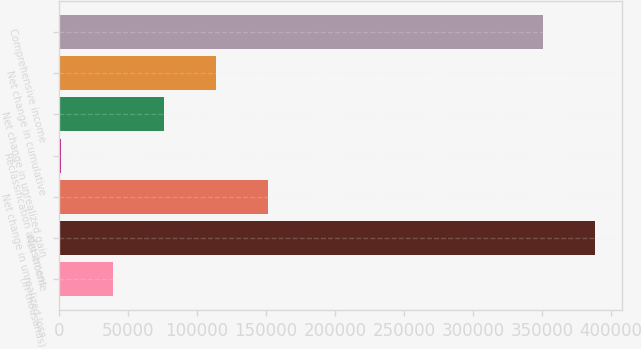Convert chart. <chart><loc_0><loc_0><loc_500><loc_500><bar_chart><fcel>(In thousands)<fcel>Net income<fcel>Net change in unrealized loss<fcel>Reclassification adjustment<fcel>Net change in unrealized gain<fcel>Net change in cumulative<fcel>Comprehensive income<nl><fcel>39022<fcel>388380<fcel>151228<fcel>1620<fcel>76424<fcel>113826<fcel>350978<nl></chart> 